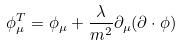<formula> <loc_0><loc_0><loc_500><loc_500>\phi ^ { T } _ { \mu } = \phi _ { \mu } + \frac { \lambda } { m ^ { 2 } } \partial _ { \mu } ( \partial \cdot \phi )</formula> 